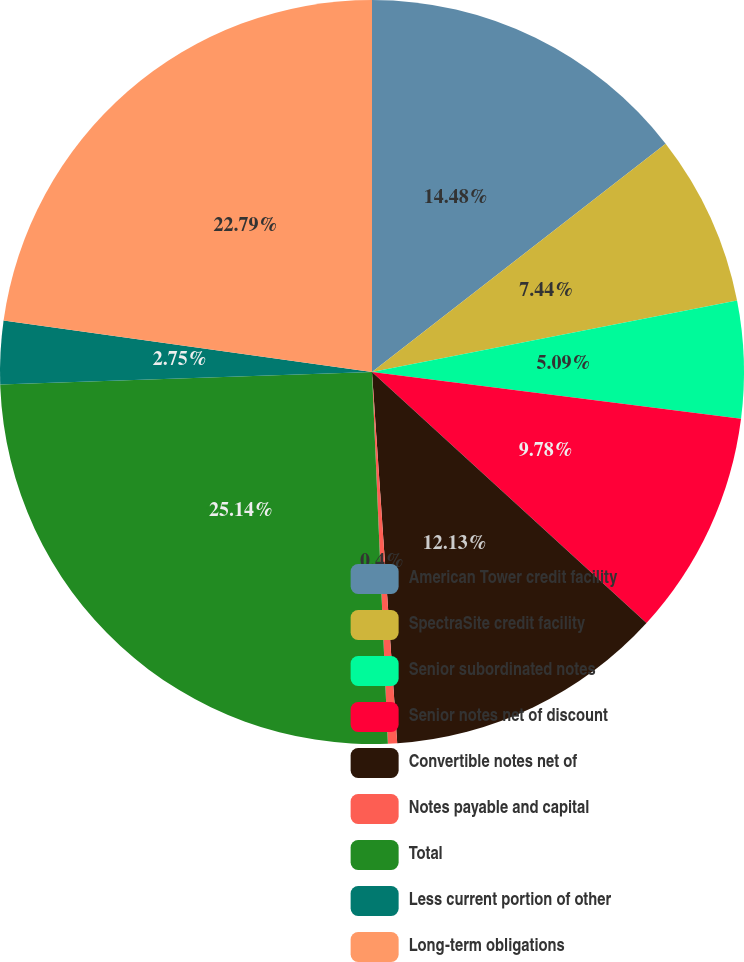Convert chart to OTSL. <chart><loc_0><loc_0><loc_500><loc_500><pie_chart><fcel>American Tower credit facility<fcel>SpectraSite credit facility<fcel>Senior subordinated notes<fcel>Senior notes net of discount<fcel>Convertible notes net of<fcel>Notes payable and capital<fcel>Total<fcel>Less current portion of other<fcel>Long-term obligations<nl><fcel>14.48%<fcel>7.44%<fcel>5.09%<fcel>9.78%<fcel>12.13%<fcel>0.4%<fcel>25.14%<fcel>2.75%<fcel>22.79%<nl></chart> 